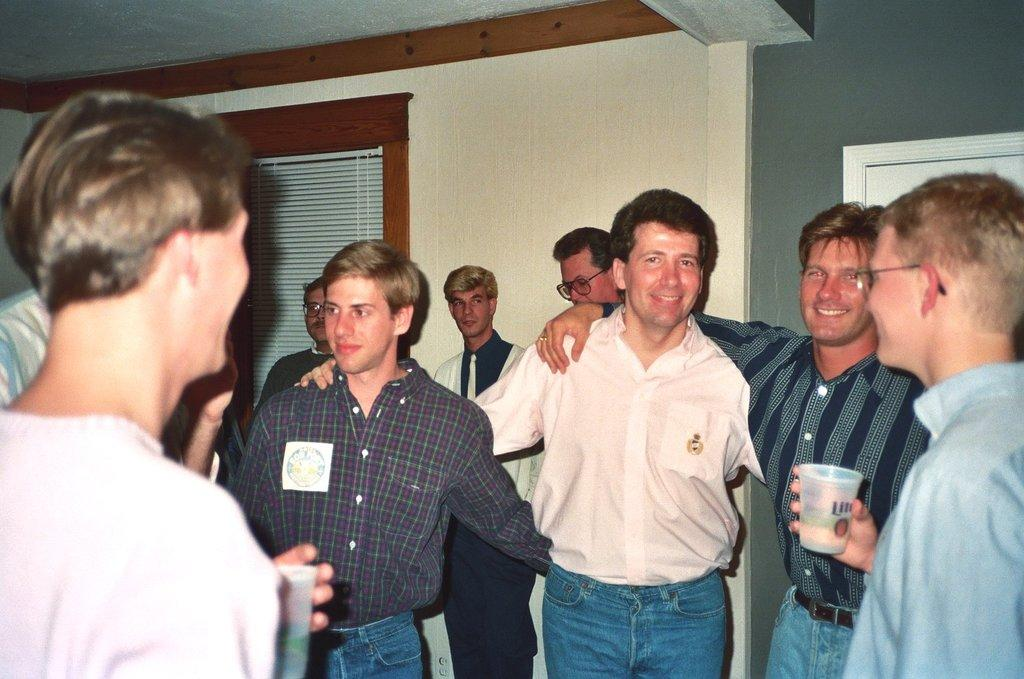What are the people in the image doing? There are people standing in the image. Can you describe what the people holding glasses are doing? Two people are holding glasses in the image. What can be seen in the background of the image? There is a wall visible in the background of the image. How many cactus plants can be seen growing near the people in the image? There are no cactus plants visible in the image. What type of seed is being used to grow the plants in the image? There are no plants visible in the image, so it is impossible to determine the type of seed being used. 